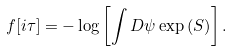<formula> <loc_0><loc_0><loc_500><loc_500>f [ i \tau ] = - \log \left [ \int D \psi \exp \left ( S \right ) \right ] .</formula> 